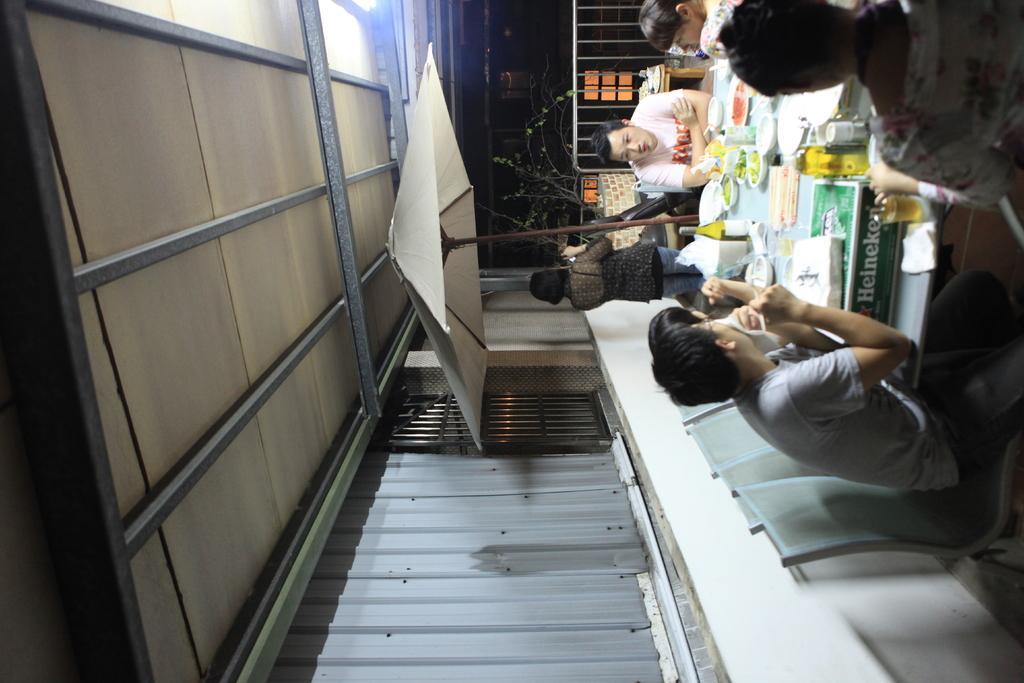How would you summarize this image in a sentence or two? On the right side of the image there is a table with bottles, bowls, plates and some other things. Around the table there are few people sitting on the chairs. Behind them there is a person standing and also there is a pole with an umbrella. At the bottom of the image there is a wall with black rods and some other things. On the left corner of the image there is a roof with rods. In the background there is a plant with leaves and also there is a gate. 